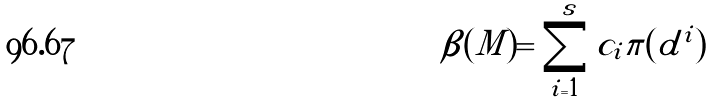Convert formula to latex. <formula><loc_0><loc_0><loc_500><loc_500>\beta ( M ) = \sum _ { i = 1 } ^ { s } c _ { i } \pi ( d ^ { i } )</formula> 